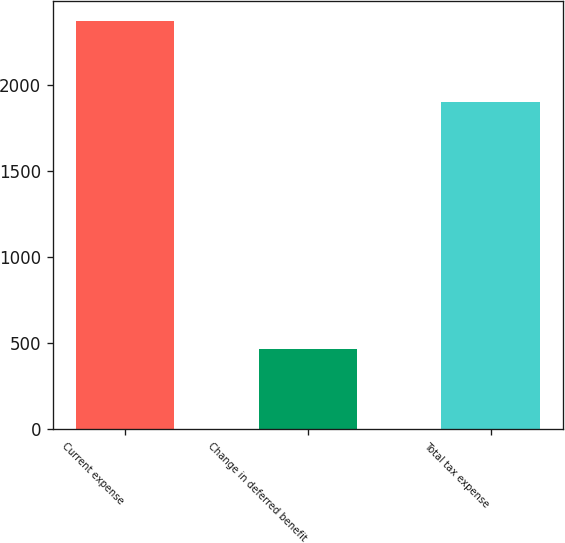<chart> <loc_0><loc_0><loc_500><loc_500><bar_chart><fcel>Current expense<fcel>Change in deferred benefit<fcel>Total tax expense<nl><fcel>2368<fcel>467<fcel>1901<nl></chart> 